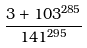Convert formula to latex. <formula><loc_0><loc_0><loc_500><loc_500>\frac { 3 + 1 0 3 ^ { 2 8 5 } } { 1 4 1 ^ { 2 9 5 } }</formula> 